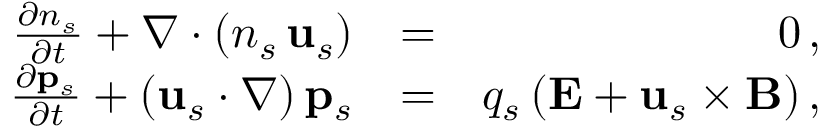<formula> <loc_0><loc_0><loc_500><loc_500>\begin{array} { r l r } { \frac { \partial n _ { s } } { \partial t } + \nabla \cdot \left ( n _ { s } \, { u } _ { s } \right ) } & { = } & { 0 \, , } \\ { \frac { \partial { p } _ { s } } { \partial t } + \left ( { u } _ { s } \cdot \nabla \right ) { p } _ { s } } & { = } & { q _ { s } \, ( { E } + { u } _ { s } \times { B } ) \, , } \end{array}</formula> 